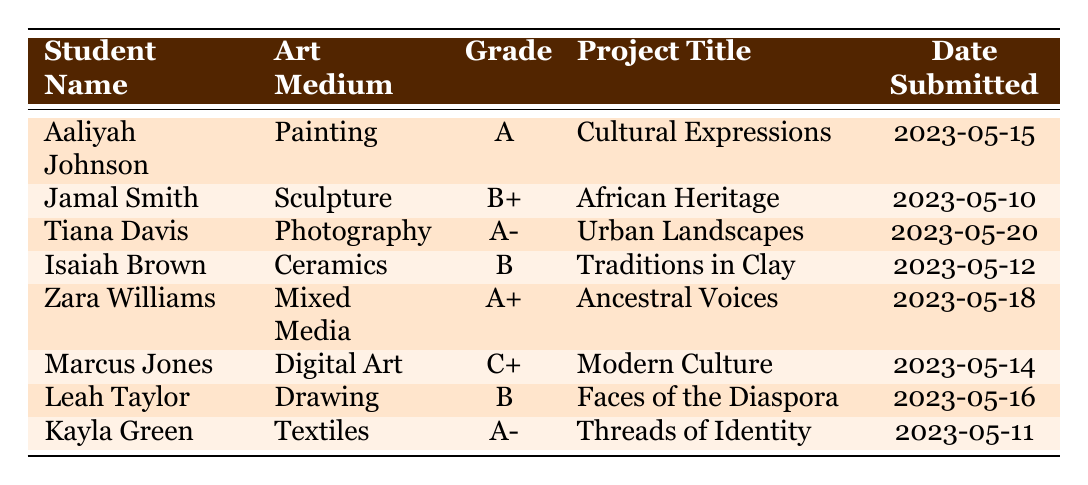What is the highest grade achieved by a student in the Painting medium? Aaliyah Johnson received an A in Painting, which is the highest grade indicated for that medium.
Answer: A How many students submitted projects in the Mixed Media medium? Only one student, Zara Williams, submitted a project in Mixed Media.
Answer: 1 Did Marcus Jones receive a grade higher than a B in any of the art mediums? Marcus Jones received a C+ for his Digital Art project, which is not higher than B, making the answer no.
Answer: No What was the date submitted for Tiana Davis's Photography project? Tiana Davis submitted her Photography project on May 20, 2023, as shown in the respective row.
Answer: 2023-05-20 Which student achieved the lowest grade across all mediums? Marcus Jones received the lowest grade with a C+ in Digital Art, lower than all other students’ grades.
Answer: C+ What is the average grade for projects in the Textiles medium? Kayla Green is the only student in Textiles and received an A-. Therefore, the average is also A-.
Answer: A- Which project title was submitted last according to the date? The last project submitted based on the date is "Urban Landscapes" by Tiana Davis on May 20, 2023.
Answer: Urban Landscapes How many students received an A or higher in their projects? Four students achieved A or higher grades: Aaliyah Johnson (A), Zara Williams (A+), Tiana Davis (A-), and Kayla Green (A-). Thus, the answer is four.
Answer: 4 Was there any student who scored a B+? Yes, Jamal Smith scored a B+ for his Sculpture project titled "African Heritage."
Answer: Yes 